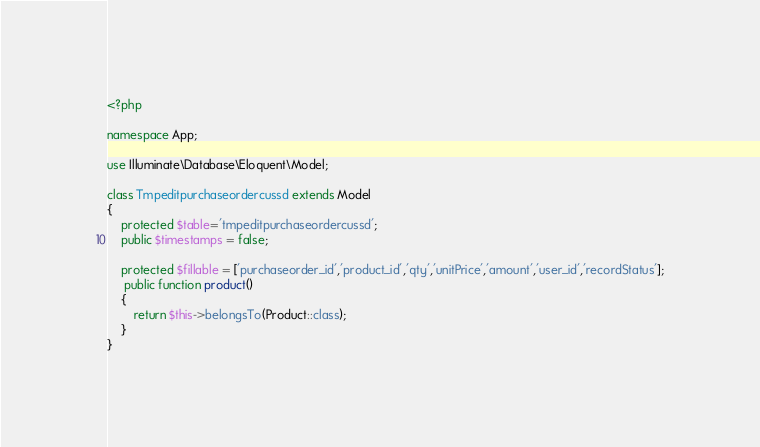<code> <loc_0><loc_0><loc_500><loc_500><_PHP_><?php

namespace App;

use Illuminate\Database\Eloquent\Model;

class Tmpeditpurchaseordercussd extends Model
{
    protected $table='tmpeditpurchaseordercussd';
    public $timestamps = false;

    protected $fillable = ['purchaseorder_id','product_id','qty','unitPrice','amount','user_id','recordStatus'];
     public function product()
    {
    	return $this->belongsTo(Product::class);
    }
}
</code> 